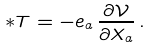<formula> <loc_0><loc_0><loc_500><loc_500>\ast T = - e _ { a } \, \frac { \partial \mathcal { V } } { \partial X _ { a } } \, .</formula> 